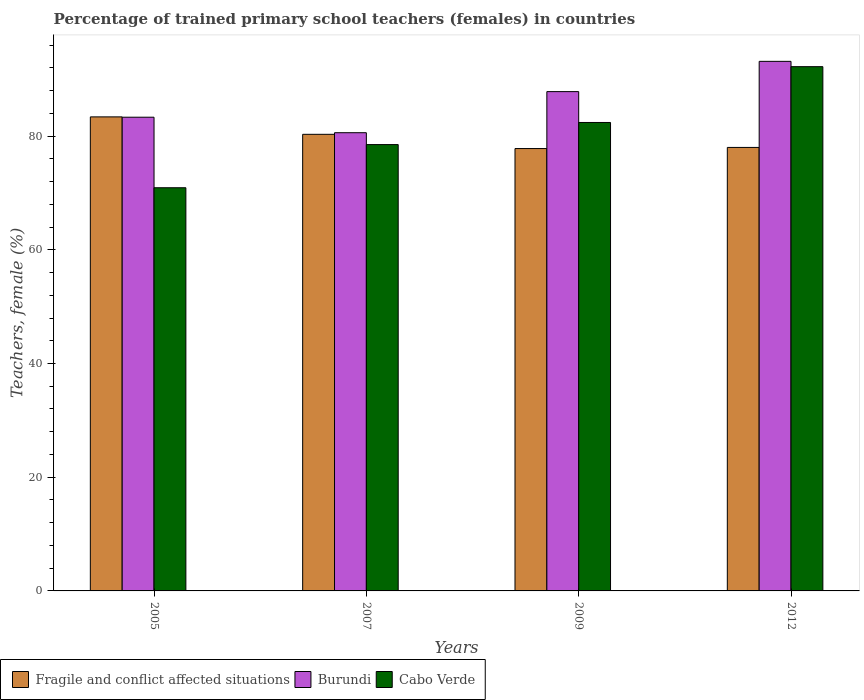Are the number of bars per tick equal to the number of legend labels?
Offer a very short reply. Yes. How many bars are there on the 3rd tick from the left?
Offer a terse response. 3. What is the percentage of trained primary school teachers (females) in Cabo Verde in 2005?
Give a very brief answer. 70.91. Across all years, what is the maximum percentage of trained primary school teachers (females) in Burundi?
Provide a short and direct response. 93.14. Across all years, what is the minimum percentage of trained primary school teachers (females) in Burundi?
Provide a short and direct response. 80.59. In which year was the percentage of trained primary school teachers (females) in Burundi maximum?
Your answer should be compact. 2012. What is the total percentage of trained primary school teachers (females) in Burundi in the graph?
Make the answer very short. 344.88. What is the difference between the percentage of trained primary school teachers (females) in Burundi in 2007 and that in 2009?
Offer a very short reply. -7.23. What is the difference between the percentage of trained primary school teachers (females) in Burundi in 2007 and the percentage of trained primary school teachers (females) in Fragile and conflict affected situations in 2005?
Ensure brevity in your answer.  -2.78. What is the average percentage of trained primary school teachers (females) in Fragile and conflict affected situations per year?
Provide a short and direct response. 79.88. In the year 2007, what is the difference between the percentage of trained primary school teachers (females) in Fragile and conflict affected situations and percentage of trained primary school teachers (females) in Cabo Verde?
Offer a very short reply. 1.81. In how many years, is the percentage of trained primary school teachers (females) in Cabo Verde greater than 52 %?
Offer a terse response. 4. What is the ratio of the percentage of trained primary school teachers (females) in Cabo Verde in 2005 to that in 2007?
Provide a succinct answer. 0.9. Is the percentage of trained primary school teachers (females) in Burundi in 2009 less than that in 2012?
Keep it short and to the point. Yes. What is the difference between the highest and the second highest percentage of trained primary school teachers (females) in Burundi?
Your response must be concise. 5.32. What is the difference between the highest and the lowest percentage of trained primary school teachers (females) in Burundi?
Give a very brief answer. 12.55. In how many years, is the percentage of trained primary school teachers (females) in Burundi greater than the average percentage of trained primary school teachers (females) in Burundi taken over all years?
Make the answer very short. 2. What does the 3rd bar from the left in 2009 represents?
Keep it short and to the point. Cabo Verde. What does the 1st bar from the right in 2005 represents?
Offer a very short reply. Cabo Verde. Is it the case that in every year, the sum of the percentage of trained primary school teachers (females) in Burundi and percentage of trained primary school teachers (females) in Fragile and conflict affected situations is greater than the percentage of trained primary school teachers (females) in Cabo Verde?
Your answer should be very brief. Yes. Are all the bars in the graph horizontal?
Ensure brevity in your answer.  No. How many years are there in the graph?
Your response must be concise. 4. What is the difference between two consecutive major ticks on the Y-axis?
Make the answer very short. 20. Does the graph contain grids?
Offer a terse response. No. Where does the legend appear in the graph?
Make the answer very short. Bottom left. How many legend labels are there?
Provide a succinct answer. 3. How are the legend labels stacked?
Keep it short and to the point. Horizontal. What is the title of the graph?
Give a very brief answer. Percentage of trained primary school teachers (females) in countries. What is the label or title of the X-axis?
Your response must be concise. Years. What is the label or title of the Y-axis?
Your answer should be very brief. Teachers, female (%). What is the Teachers, female (%) in Fragile and conflict affected situations in 2005?
Keep it short and to the point. 83.38. What is the Teachers, female (%) of Burundi in 2005?
Provide a short and direct response. 83.32. What is the Teachers, female (%) of Cabo Verde in 2005?
Your answer should be compact. 70.91. What is the Teachers, female (%) of Fragile and conflict affected situations in 2007?
Offer a very short reply. 80.31. What is the Teachers, female (%) in Burundi in 2007?
Give a very brief answer. 80.59. What is the Teachers, female (%) in Cabo Verde in 2007?
Provide a short and direct response. 78.5. What is the Teachers, female (%) in Fragile and conflict affected situations in 2009?
Your answer should be very brief. 77.81. What is the Teachers, female (%) of Burundi in 2009?
Offer a terse response. 87.82. What is the Teachers, female (%) in Cabo Verde in 2009?
Provide a succinct answer. 82.39. What is the Teachers, female (%) in Fragile and conflict affected situations in 2012?
Provide a short and direct response. 78.01. What is the Teachers, female (%) in Burundi in 2012?
Provide a succinct answer. 93.14. What is the Teachers, female (%) in Cabo Verde in 2012?
Offer a very short reply. 92.21. Across all years, what is the maximum Teachers, female (%) of Fragile and conflict affected situations?
Ensure brevity in your answer.  83.38. Across all years, what is the maximum Teachers, female (%) of Burundi?
Offer a terse response. 93.14. Across all years, what is the maximum Teachers, female (%) of Cabo Verde?
Offer a terse response. 92.21. Across all years, what is the minimum Teachers, female (%) in Fragile and conflict affected situations?
Keep it short and to the point. 77.81. Across all years, what is the minimum Teachers, female (%) in Burundi?
Provide a short and direct response. 80.59. Across all years, what is the minimum Teachers, female (%) in Cabo Verde?
Your answer should be very brief. 70.91. What is the total Teachers, female (%) of Fragile and conflict affected situations in the graph?
Offer a very short reply. 319.5. What is the total Teachers, female (%) in Burundi in the graph?
Your response must be concise. 344.88. What is the total Teachers, female (%) in Cabo Verde in the graph?
Offer a very short reply. 324.02. What is the difference between the Teachers, female (%) of Fragile and conflict affected situations in 2005 and that in 2007?
Give a very brief answer. 3.07. What is the difference between the Teachers, female (%) in Burundi in 2005 and that in 2007?
Ensure brevity in your answer.  2.73. What is the difference between the Teachers, female (%) in Cabo Verde in 2005 and that in 2007?
Offer a very short reply. -7.59. What is the difference between the Teachers, female (%) in Fragile and conflict affected situations in 2005 and that in 2009?
Make the answer very short. 5.57. What is the difference between the Teachers, female (%) of Burundi in 2005 and that in 2009?
Offer a terse response. -4.5. What is the difference between the Teachers, female (%) in Cabo Verde in 2005 and that in 2009?
Keep it short and to the point. -11.48. What is the difference between the Teachers, female (%) in Fragile and conflict affected situations in 2005 and that in 2012?
Offer a very short reply. 5.37. What is the difference between the Teachers, female (%) in Burundi in 2005 and that in 2012?
Make the answer very short. -9.82. What is the difference between the Teachers, female (%) in Cabo Verde in 2005 and that in 2012?
Your answer should be compact. -21.3. What is the difference between the Teachers, female (%) in Fragile and conflict affected situations in 2007 and that in 2009?
Provide a short and direct response. 2.5. What is the difference between the Teachers, female (%) in Burundi in 2007 and that in 2009?
Your response must be concise. -7.23. What is the difference between the Teachers, female (%) in Cabo Verde in 2007 and that in 2009?
Give a very brief answer. -3.89. What is the difference between the Teachers, female (%) of Fragile and conflict affected situations in 2007 and that in 2012?
Provide a succinct answer. 2.31. What is the difference between the Teachers, female (%) of Burundi in 2007 and that in 2012?
Give a very brief answer. -12.55. What is the difference between the Teachers, female (%) of Cabo Verde in 2007 and that in 2012?
Offer a terse response. -13.71. What is the difference between the Teachers, female (%) of Fragile and conflict affected situations in 2009 and that in 2012?
Your answer should be very brief. -0.2. What is the difference between the Teachers, female (%) in Burundi in 2009 and that in 2012?
Provide a succinct answer. -5.32. What is the difference between the Teachers, female (%) in Cabo Verde in 2009 and that in 2012?
Your answer should be compact. -9.82. What is the difference between the Teachers, female (%) of Fragile and conflict affected situations in 2005 and the Teachers, female (%) of Burundi in 2007?
Make the answer very short. 2.78. What is the difference between the Teachers, female (%) of Fragile and conflict affected situations in 2005 and the Teachers, female (%) of Cabo Verde in 2007?
Make the answer very short. 4.87. What is the difference between the Teachers, female (%) of Burundi in 2005 and the Teachers, female (%) of Cabo Verde in 2007?
Offer a terse response. 4.82. What is the difference between the Teachers, female (%) in Fragile and conflict affected situations in 2005 and the Teachers, female (%) in Burundi in 2009?
Offer a very short reply. -4.44. What is the difference between the Teachers, female (%) in Fragile and conflict affected situations in 2005 and the Teachers, female (%) in Cabo Verde in 2009?
Your answer should be compact. 0.98. What is the difference between the Teachers, female (%) of Burundi in 2005 and the Teachers, female (%) of Cabo Verde in 2009?
Offer a terse response. 0.93. What is the difference between the Teachers, female (%) of Fragile and conflict affected situations in 2005 and the Teachers, female (%) of Burundi in 2012?
Provide a short and direct response. -9.77. What is the difference between the Teachers, female (%) of Fragile and conflict affected situations in 2005 and the Teachers, female (%) of Cabo Verde in 2012?
Ensure brevity in your answer.  -8.83. What is the difference between the Teachers, female (%) in Burundi in 2005 and the Teachers, female (%) in Cabo Verde in 2012?
Offer a very short reply. -8.89. What is the difference between the Teachers, female (%) of Fragile and conflict affected situations in 2007 and the Teachers, female (%) of Burundi in 2009?
Ensure brevity in your answer.  -7.51. What is the difference between the Teachers, female (%) of Fragile and conflict affected situations in 2007 and the Teachers, female (%) of Cabo Verde in 2009?
Keep it short and to the point. -2.08. What is the difference between the Teachers, female (%) of Burundi in 2007 and the Teachers, female (%) of Cabo Verde in 2009?
Provide a succinct answer. -1.8. What is the difference between the Teachers, female (%) of Fragile and conflict affected situations in 2007 and the Teachers, female (%) of Burundi in 2012?
Your answer should be very brief. -12.83. What is the difference between the Teachers, female (%) in Fragile and conflict affected situations in 2007 and the Teachers, female (%) in Cabo Verde in 2012?
Offer a very short reply. -11.9. What is the difference between the Teachers, female (%) in Burundi in 2007 and the Teachers, female (%) in Cabo Verde in 2012?
Offer a very short reply. -11.62. What is the difference between the Teachers, female (%) in Fragile and conflict affected situations in 2009 and the Teachers, female (%) in Burundi in 2012?
Provide a short and direct response. -15.34. What is the difference between the Teachers, female (%) in Fragile and conflict affected situations in 2009 and the Teachers, female (%) in Cabo Verde in 2012?
Ensure brevity in your answer.  -14.4. What is the difference between the Teachers, female (%) of Burundi in 2009 and the Teachers, female (%) of Cabo Verde in 2012?
Offer a terse response. -4.39. What is the average Teachers, female (%) of Fragile and conflict affected situations per year?
Offer a terse response. 79.88. What is the average Teachers, female (%) of Burundi per year?
Your response must be concise. 86.22. What is the average Teachers, female (%) in Cabo Verde per year?
Offer a terse response. 81.01. In the year 2005, what is the difference between the Teachers, female (%) of Fragile and conflict affected situations and Teachers, female (%) of Burundi?
Offer a very short reply. 0.06. In the year 2005, what is the difference between the Teachers, female (%) of Fragile and conflict affected situations and Teachers, female (%) of Cabo Verde?
Offer a terse response. 12.46. In the year 2005, what is the difference between the Teachers, female (%) in Burundi and Teachers, female (%) in Cabo Verde?
Make the answer very short. 12.41. In the year 2007, what is the difference between the Teachers, female (%) of Fragile and conflict affected situations and Teachers, female (%) of Burundi?
Offer a terse response. -0.28. In the year 2007, what is the difference between the Teachers, female (%) of Fragile and conflict affected situations and Teachers, female (%) of Cabo Verde?
Ensure brevity in your answer.  1.81. In the year 2007, what is the difference between the Teachers, female (%) of Burundi and Teachers, female (%) of Cabo Verde?
Your response must be concise. 2.09. In the year 2009, what is the difference between the Teachers, female (%) in Fragile and conflict affected situations and Teachers, female (%) in Burundi?
Your response must be concise. -10.02. In the year 2009, what is the difference between the Teachers, female (%) of Fragile and conflict affected situations and Teachers, female (%) of Cabo Verde?
Ensure brevity in your answer.  -4.59. In the year 2009, what is the difference between the Teachers, female (%) in Burundi and Teachers, female (%) in Cabo Verde?
Provide a succinct answer. 5.43. In the year 2012, what is the difference between the Teachers, female (%) in Fragile and conflict affected situations and Teachers, female (%) in Burundi?
Provide a short and direct response. -15.14. In the year 2012, what is the difference between the Teachers, female (%) in Fragile and conflict affected situations and Teachers, female (%) in Cabo Verde?
Make the answer very short. -14.2. In the year 2012, what is the difference between the Teachers, female (%) of Burundi and Teachers, female (%) of Cabo Verde?
Keep it short and to the point. 0.93. What is the ratio of the Teachers, female (%) in Fragile and conflict affected situations in 2005 to that in 2007?
Your answer should be very brief. 1.04. What is the ratio of the Teachers, female (%) of Burundi in 2005 to that in 2007?
Give a very brief answer. 1.03. What is the ratio of the Teachers, female (%) of Cabo Verde in 2005 to that in 2007?
Provide a short and direct response. 0.9. What is the ratio of the Teachers, female (%) of Fragile and conflict affected situations in 2005 to that in 2009?
Offer a very short reply. 1.07. What is the ratio of the Teachers, female (%) in Burundi in 2005 to that in 2009?
Offer a very short reply. 0.95. What is the ratio of the Teachers, female (%) of Cabo Verde in 2005 to that in 2009?
Offer a terse response. 0.86. What is the ratio of the Teachers, female (%) in Fragile and conflict affected situations in 2005 to that in 2012?
Offer a terse response. 1.07. What is the ratio of the Teachers, female (%) in Burundi in 2005 to that in 2012?
Keep it short and to the point. 0.89. What is the ratio of the Teachers, female (%) of Cabo Verde in 2005 to that in 2012?
Provide a succinct answer. 0.77. What is the ratio of the Teachers, female (%) of Fragile and conflict affected situations in 2007 to that in 2009?
Your answer should be compact. 1.03. What is the ratio of the Teachers, female (%) in Burundi in 2007 to that in 2009?
Give a very brief answer. 0.92. What is the ratio of the Teachers, female (%) of Cabo Verde in 2007 to that in 2009?
Offer a terse response. 0.95. What is the ratio of the Teachers, female (%) in Fragile and conflict affected situations in 2007 to that in 2012?
Ensure brevity in your answer.  1.03. What is the ratio of the Teachers, female (%) in Burundi in 2007 to that in 2012?
Provide a succinct answer. 0.87. What is the ratio of the Teachers, female (%) in Cabo Verde in 2007 to that in 2012?
Make the answer very short. 0.85. What is the ratio of the Teachers, female (%) in Fragile and conflict affected situations in 2009 to that in 2012?
Ensure brevity in your answer.  1. What is the ratio of the Teachers, female (%) of Burundi in 2009 to that in 2012?
Make the answer very short. 0.94. What is the ratio of the Teachers, female (%) in Cabo Verde in 2009 to that in 2012?
Offer a very short reply. 0.89. What is the difference between the highest and the second highest Teachers, female (%) of Fragile and conflict affected situations?
Provide a short and direct response. 3.07. What is the difference between the highest and the second highest Teachers, female (%) in Burundi?
Your answer should be compact. 5.32. What is the difference between the highest and the second highest Teachers, female (%) in Cabo Verde?
Offer a terse response. 9.82. What is the difference between the highest and the lowest Teachers, female (%) in Fragile and conflict affected situations?
Keep it short and to the point. 5.57. What is the difference between the highest and the lowest Teachers, female (%) of Burundi?
Ensure brevity in your answer.  12.55. What is the difference between the highest and the lowest Teachers, female (%) in Cabo Verde?
Offer a very short reply. 21.3. 